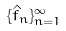<formula> <loc_0><loc_0><loc_500><loc_500>\{ \hat { f } _ { n } \} _ { n = 1 } ^ { \infty }</formula> 